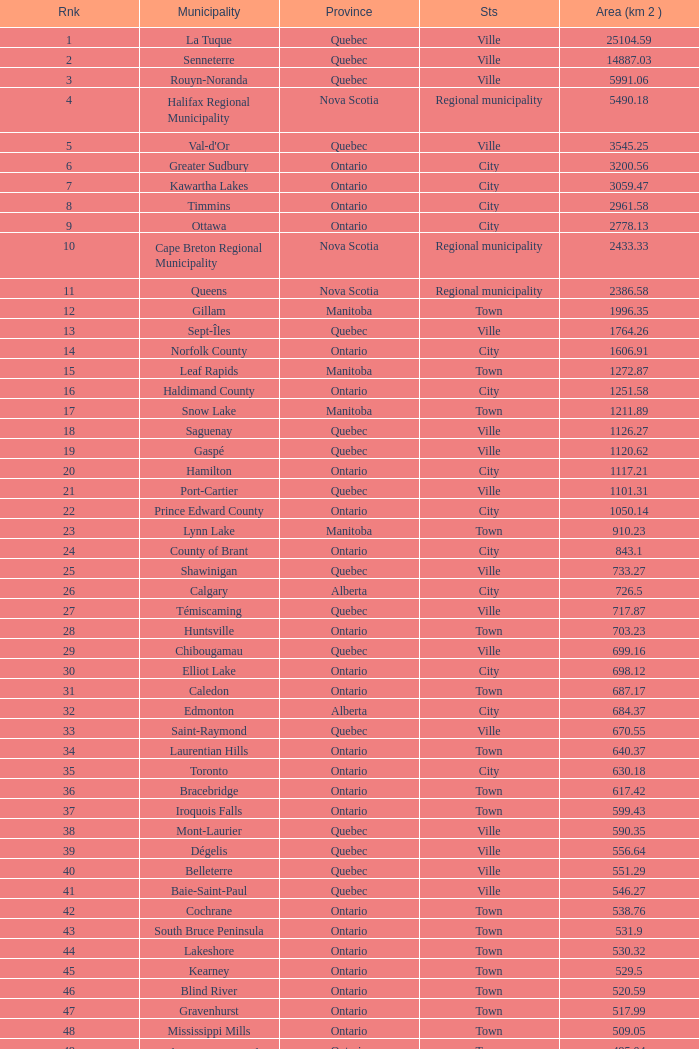What is the total Rank that has a Municipality of Winnipeg, an Area (KM 2) that's larger than 464.01? None. 